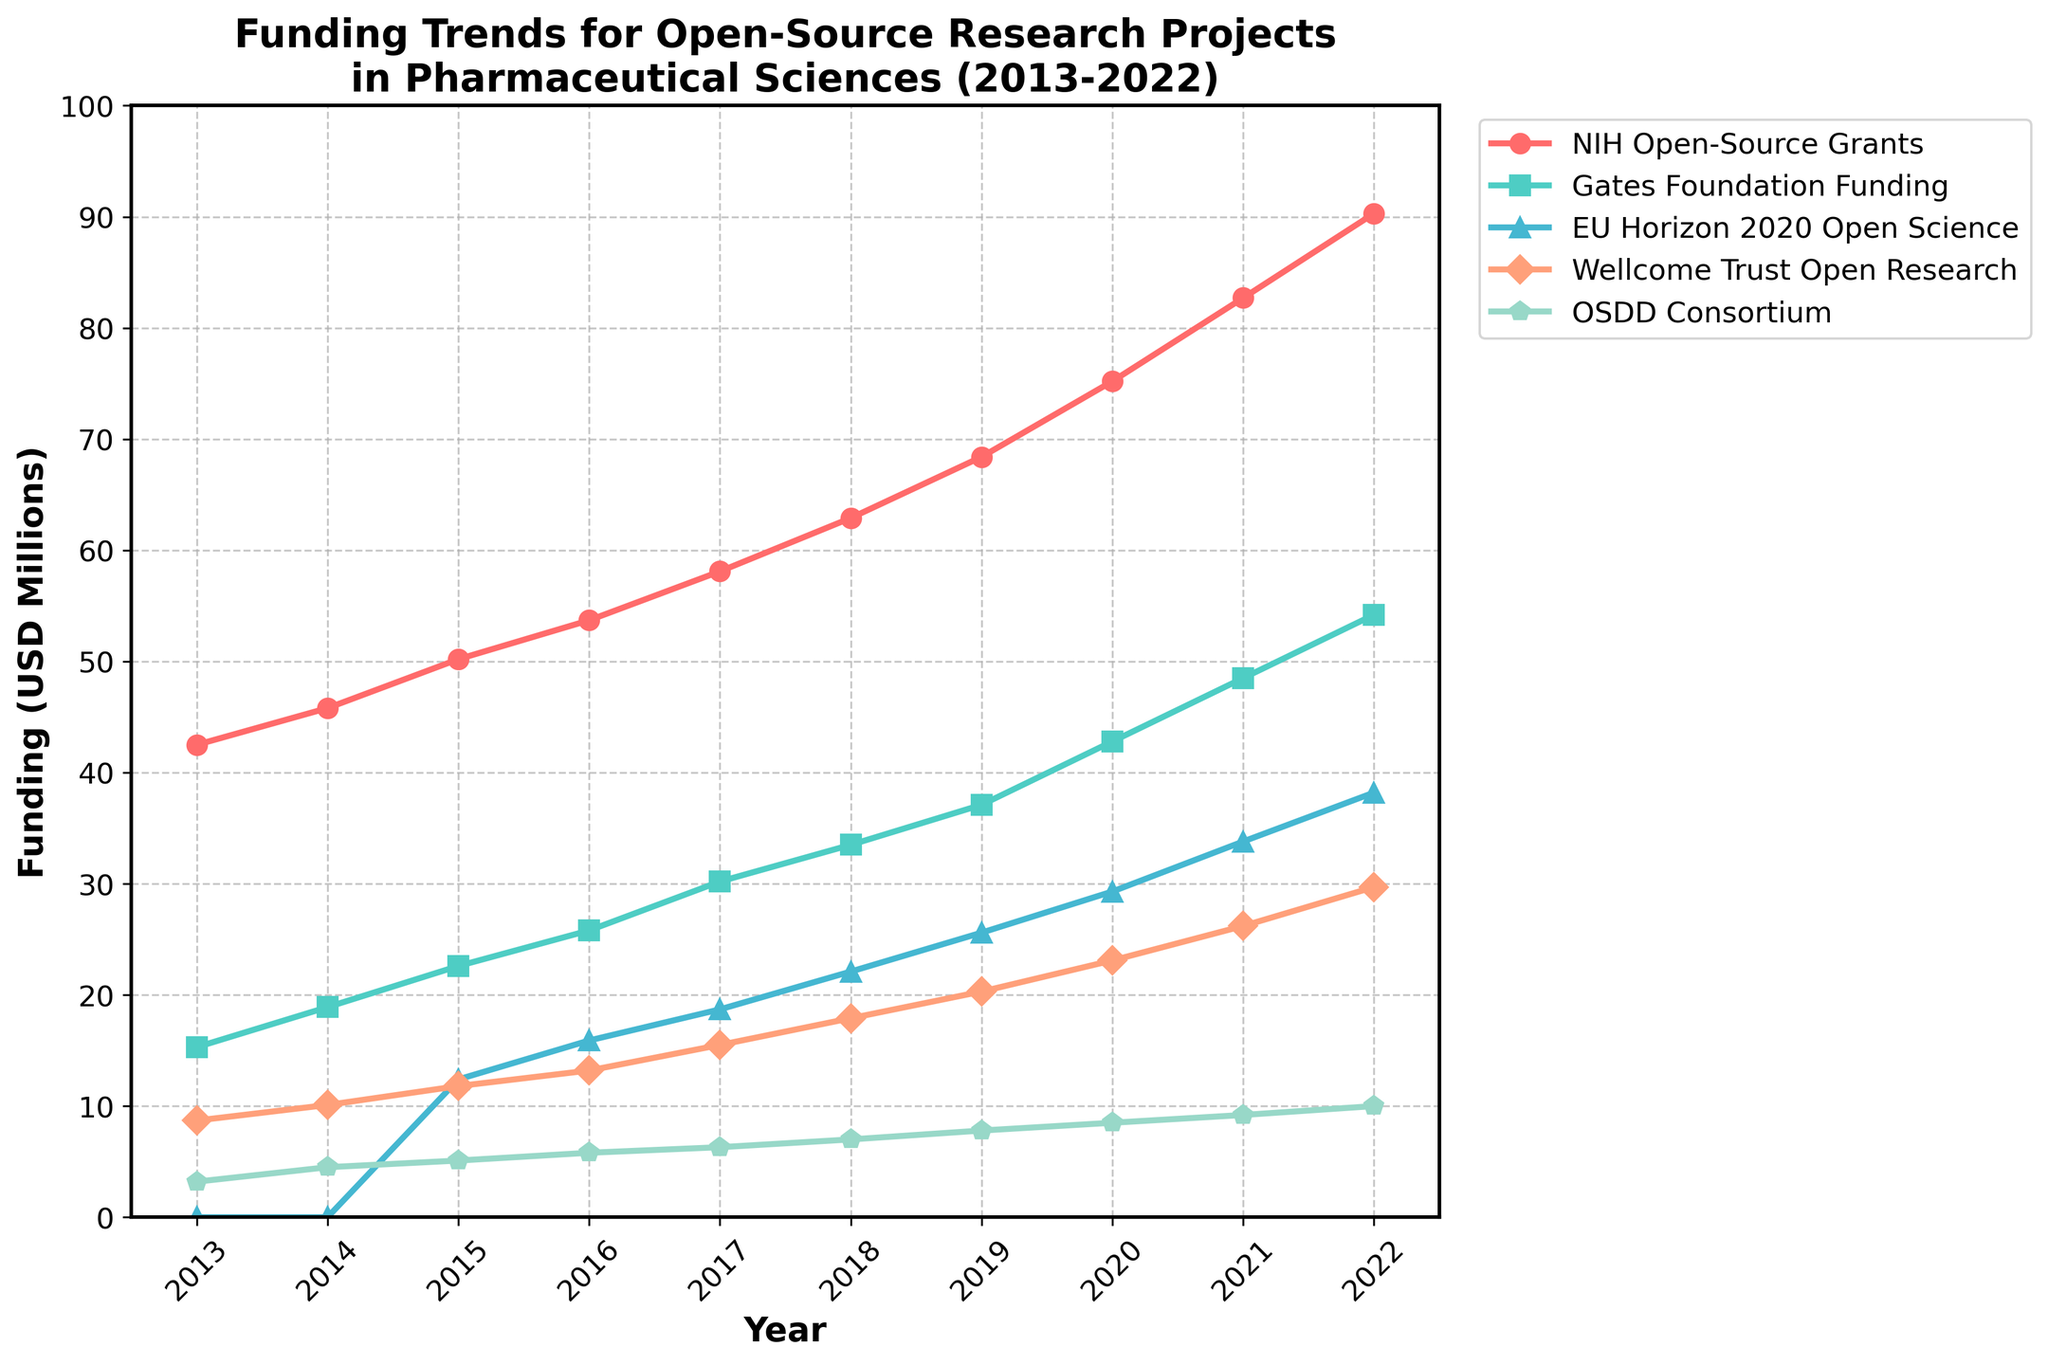What is the trend of NIH Open-Source Grants funding from 2013 to 2022? The NIH Open-Source Grants funding shows a continuous increase over the years, starting from 42.5 million USD in 2013 and reaching 90.3 million USD in 2022.
Answer: Continuous increase Which funding source had the highest funding in 2022? In 2022, the NIH Open-Source Grants had the highest funding with 90.3 million USD, followed by the Gates Foundation with 54.2 million USD, EU Horizon 2020 with 38.2 million USD, Wellcome Trust with 29.7 million USD, and OSDD Consortium with 10 million USD.
Answer: NIH Open-Source Grants How does the funding trend of the Wellcome Trust Open Research compare to that of the OSDD Consortium from 2013 to 2022? Both the Wellcome Trust Open Research and OSDD Consortium show an increasing trend over the years. However, the Wellcome Trust funding grew more substantially from 8.7 million USD in 2013 to 29.7 million USD in 2022, whereas the OSDD Consortium funding increased from 3.2 million USD in 2013 to 10 million USD in 2022.
Answer: Wellcome Trust grew more substantially Which funding source’s increase was the most significant between 2015 and 2020? To determine the most significant increase, we calculate the difference between the 2020 and 2015 funding amounts. The Gates Foundation increased from 22.6 million USD in 2015 to 42.8 million USD in 2020, leading to an increase of 20.2 million USD. Comparing to other sources, this is the most significant increase.
Answer: Gates Foundation What was the average annual funding of EU Horizon 2020 Open Science over the recorded years? The funding of the EU Horizon 2020 Open Science in the respective years (2015-2022) is summed up: 12.4, 15.9, 18.7, 22.1, 25.6, 29.3, 33.8, 38.2, giving a total of 196 million USD. Dividing this by 8 (the number of years), the average annual funding is 196/8 = 24.5 million USD.
Answer: 24.5 million USD What was the funding gap between NIH Open-Source Grants and Gates Foundation in 2021? In 2021, the NIH Open-Source Grants funding was 82.7 million USD, and the Gates Foundation funding was 48.5 million USD. The funding gap is calculated as 82.7 - 48.5 = 34.2 million USD.
Answer: 34.2 million USD Which funding source had zero funding at the beginning of the recorded period? In 2013 and 2014, the EU Horizon 2020 Open Science had zero funding as indicated in the figure where its funding starts at 12.4 million USD in 2015.
Answer: EU Horizon 2020 Open Science By how much did the funding for Wellcome Trust Open Research increase from 2013 to 2022? The funding for Wellcome Trust Open Research in 2013 was 8.7 million USD, and in 2022 it was 29.7 million USD. The increase is calculated as 29.7 - 8.7 = 21 million USD.
Answer: 21 million USD In which year did the OSDD Consortium reach half of its 2022 funding? The funding for OSDD Consortium in 2022 was 10 million USD. Half of this amount is 5 million USD. According to the data, in 2015, the funding was slightly above 5 million USD at 5.1 million USD, indicating the year it reached half of its 2022 funding.
Answer: 2015 